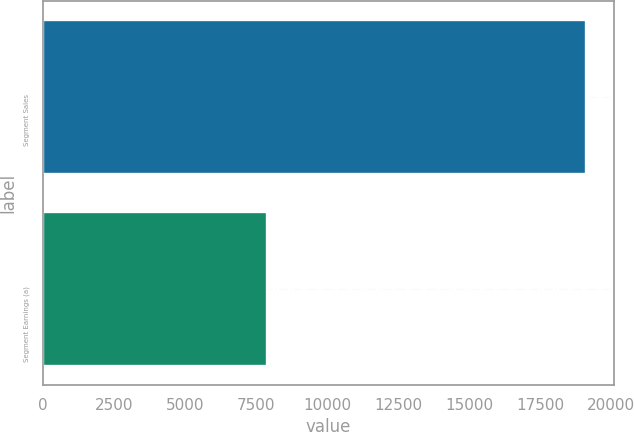Convert chart to OTSL. <chart><loc_0><loc_0><loc_500><loc_500><bar_chart><fcel>Segment Sales<fcel>Segment Earnings (a)<nl><fcel>19132<fcel>7894<nl></chart> 